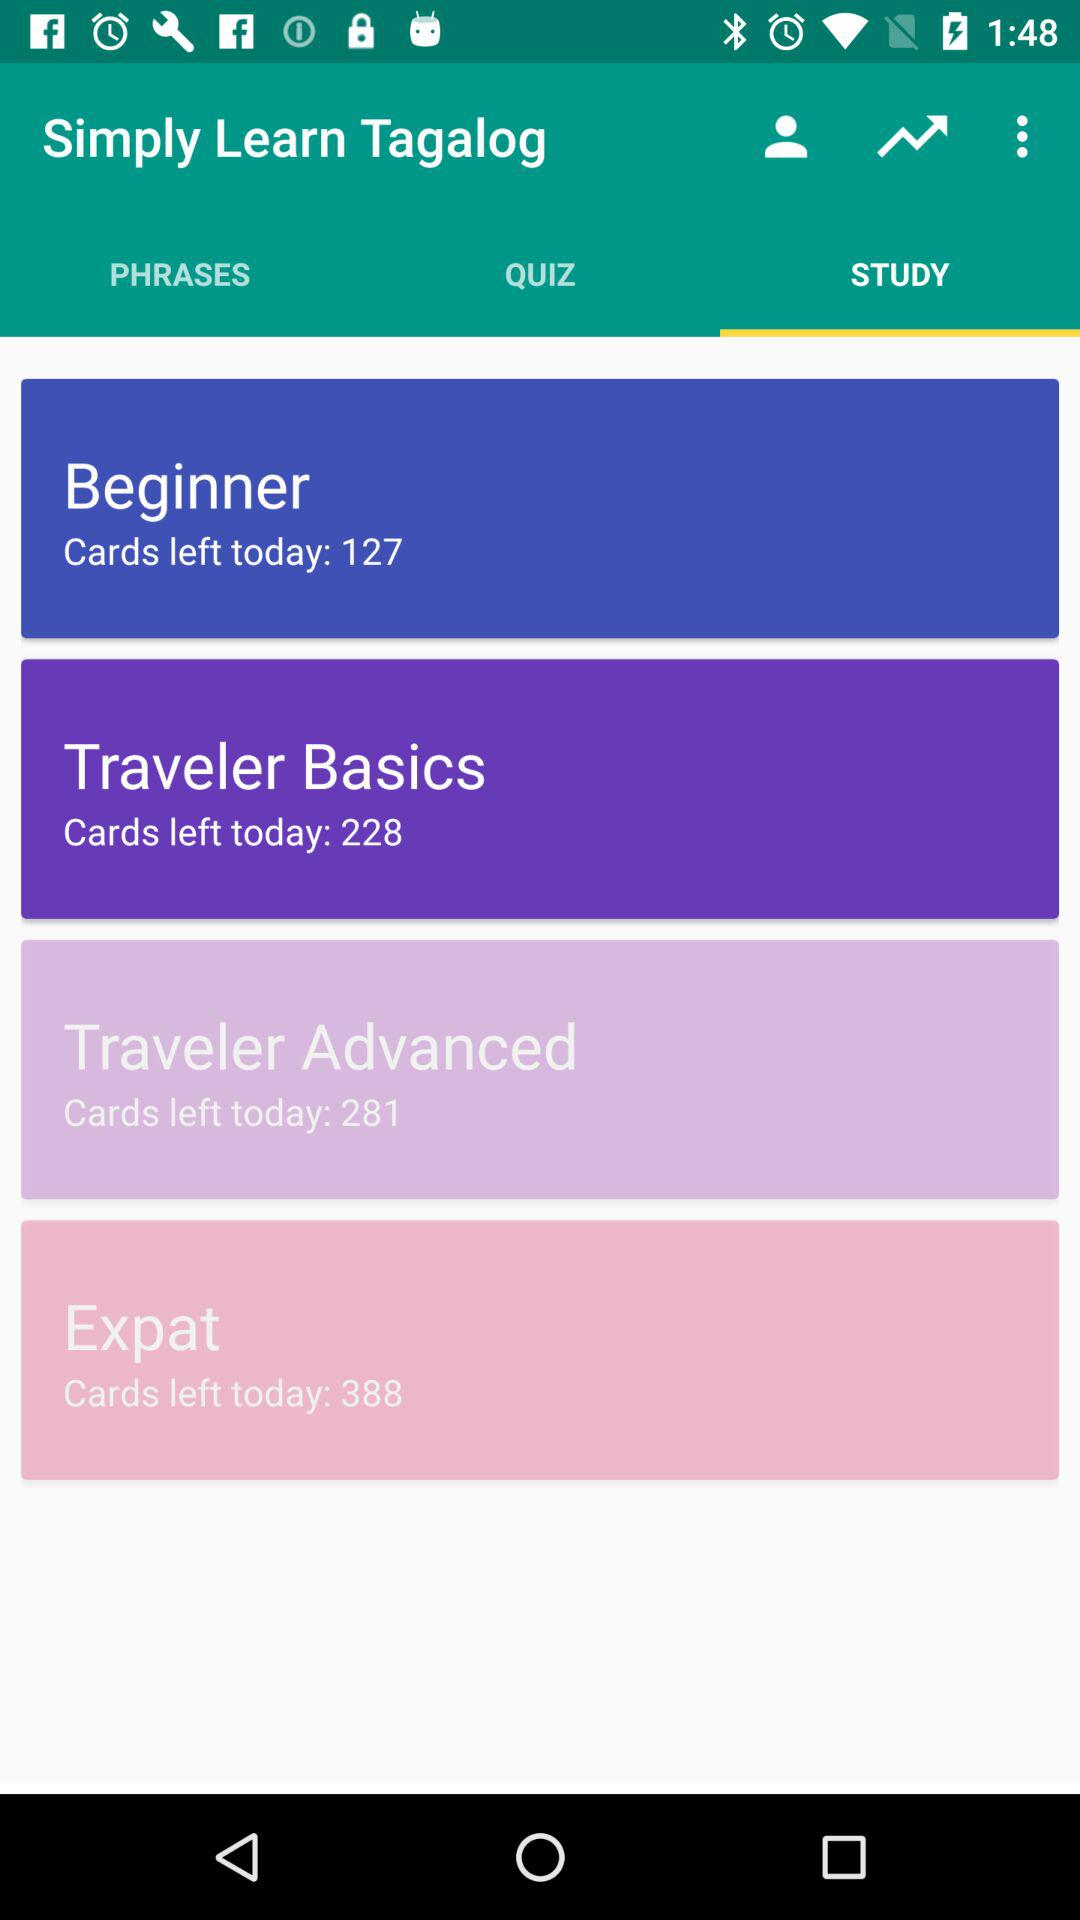Which category has 281 cards? There are 281 cards in the "Traveler Advanced" category. 